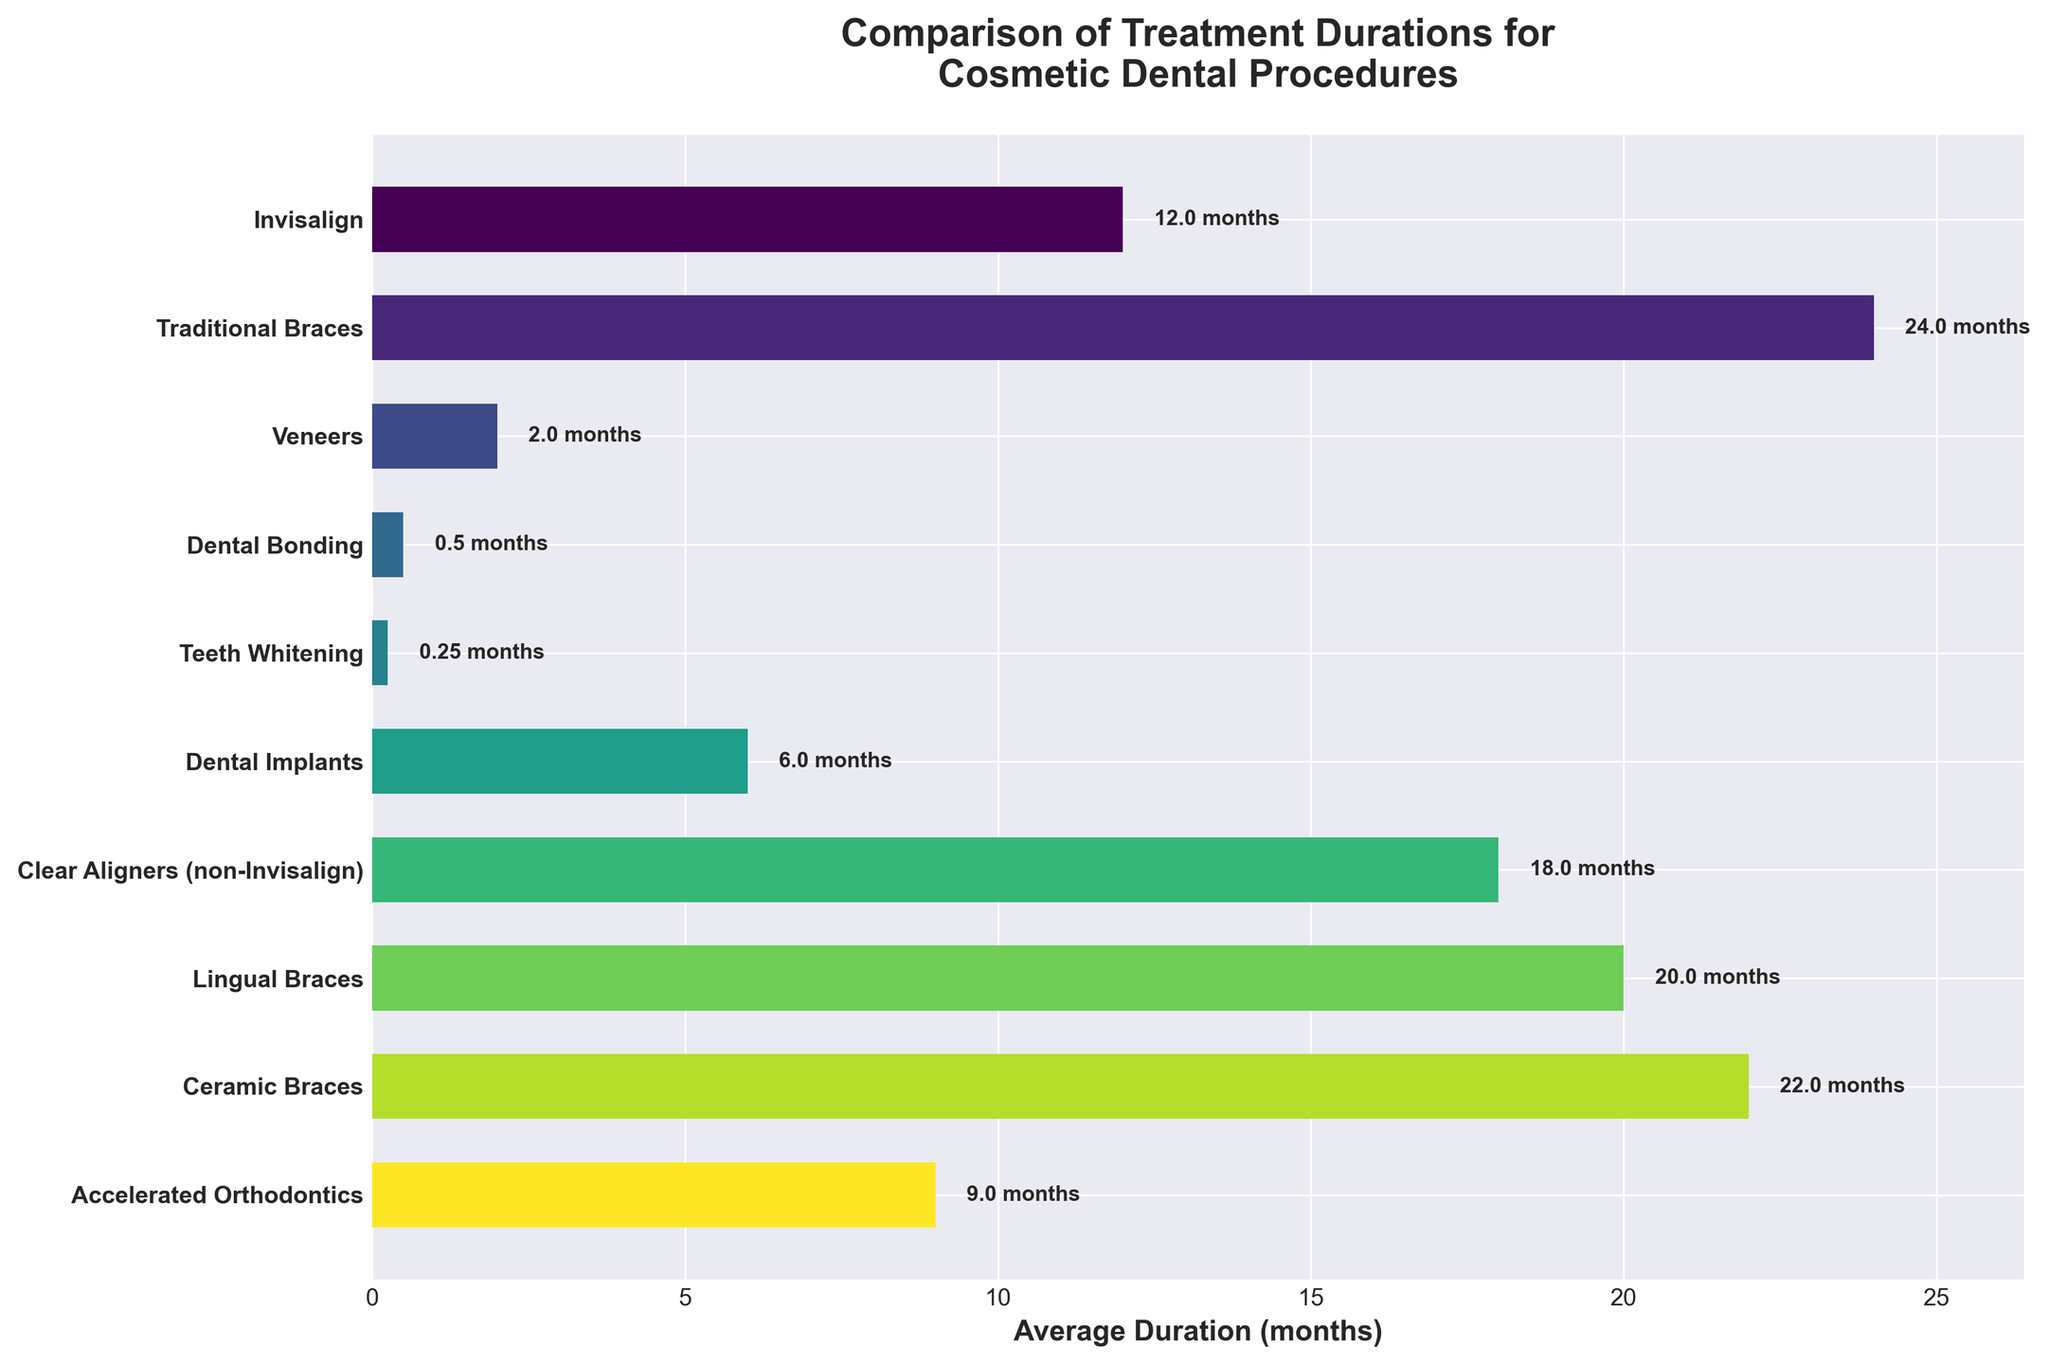What's the average duration for cosmetic dental procedures? To calculate the average, add the durations of all procedures: 12+24+2+0.5+0.25+6+18+20+22+9 = 113.75 months. Then, divide by the number of procedures (10). 113.75/10 = 11.375 months
Answer: 11.375 months Which procedure has the shortest duration? Looking at the chart, the shortest bar represents Teeth Whitening with a duration of 0.25 months.
Answer: Teeth Whitening Which procedure has the longest duration? The longest bar represents Traditional Braces with a duration of 24 months.
Answer: Traditional Braces What is the difference in duration between Invisalign and Traditional Braces? Refer to the chart for Invisalign (12 months) and Traditional Braces (24 months). The difference is 24 - 12 = 12 months.
Answer: 12 months Which procedures have a duration longer than 15 months? Observing the chart, the procedures longer than 15 months are Traditional Braces (24), Clear Aligners (non-Invisalign) (18), Lingual Braces (20), and Ceramic Braces (22).
Answer: Traditional Braces, Clear Aligners, Lingual Braces, Ceramic Braces How does the duration of Accelerated Orthodontics compare to that of Dental Implants? The chart shows Accelerated Orthodontics at 9 months and Dental Implants at 6 months. So, Accelerated Orthodontics takes 3 months longer.
Answer: 3 months longer What is the combined duration of the three shortest procedures? The three shortest procedures are Teeth Whitening (0.25), Dental Bonding (0.5), and Veneers (2). Combined duration: 0.25 + 0.5 + 2 = 2.75 months.
Answer: 2.75 months If you add the duration of Invisalign to Clear Aligners (non-Invisalign), what is the total? Referring to the chart, Invisalign is 12 months and Clear Aligners (non-Invisalign) is 18 months. The total is 12 + 18 = 30 months.
Answer: 30 months What's the median duration for the procedures? Order the durations: 0.25, 0.5, 2, 6, 9, 12, 18, 20, 22, 24. With 10 numbers, median is (12+9)/2 = 21/2 = 10.5 months.
Answer: 10.5 months Which procedure durations fall within 8 to 20 months? The procedures in this range are Accelerated Orthodontics (9), Invisalign (12), Clear Aligners (non-Invisalign) (18), and Lingual Braces (20).
Answer: Accelerated Orthodontics, Invisalign, Clear Aligners, Lingual Braces 